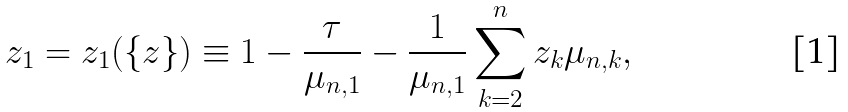Convert formula to latex. <formula><loc_0><loc_0><loc_500><loc_500>z _ { 1 } = z _ { 1 } ( \{ z \} ) \equiv 1 - \frac { \tau } { \mu _ { n , 1 } } - \frac { 1 } { \mu _ { n , 1 } } \sum _ { k = 2 } ^ { n } z _ { k } \mu _ { n , k } ,</formula> 